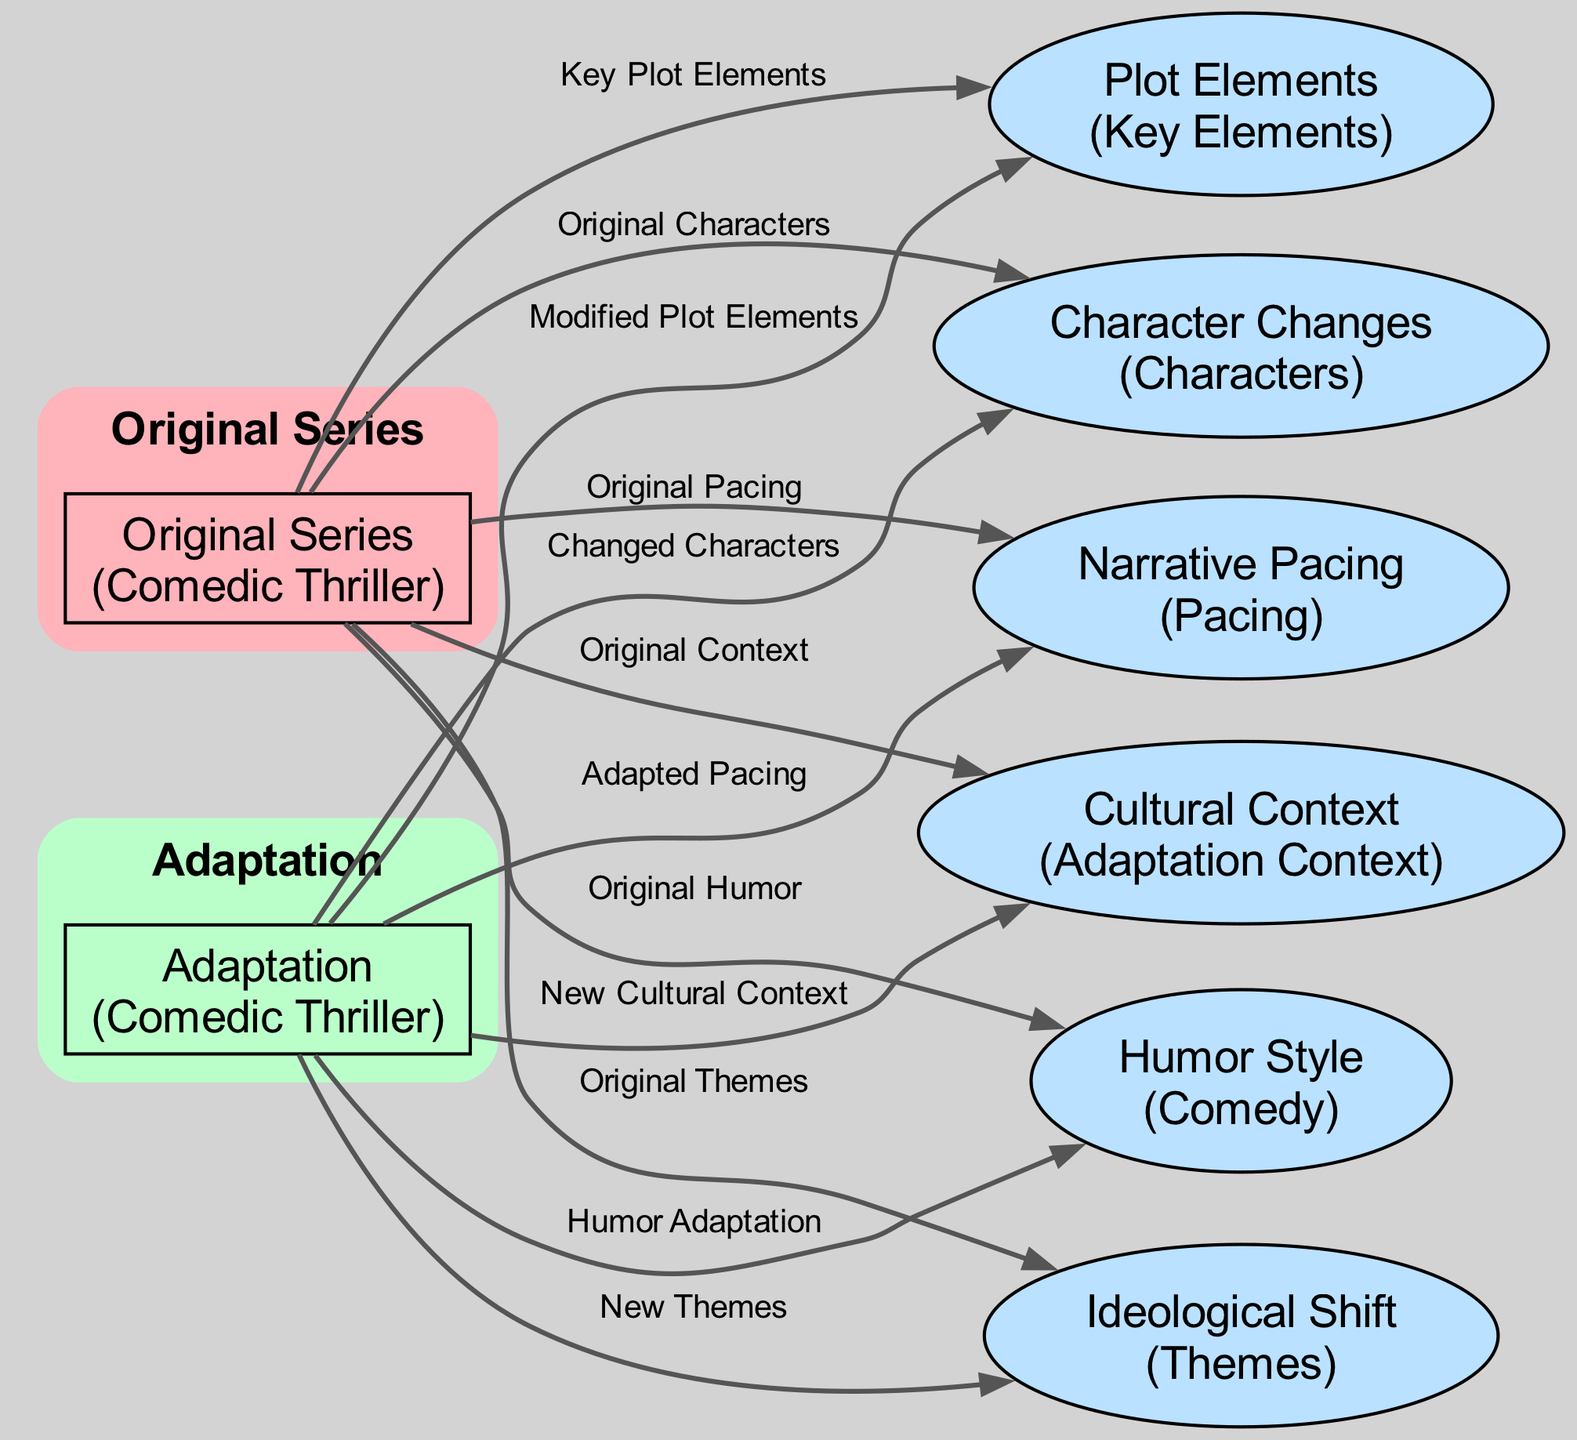What are the key plot elements of the original series? The diagram indicates that the original series has key plot elements, denoted by the edge labeled "Key Plot Elements" leading from "Original Series" to "Plot Elements."
Answer: Key Plot Elements What are the modified plot elements in the adaptation? The adaptation has modified plot elements, as labeled by the edge from "Adaptation" to "Plot Elements" marked "Modified Plot Elements."
Answer: Modified Plot Elements How many nodes are present in this diagram? Counting the nodes listed, there are a total of 7 nodes: Original Series, Adaptation, Plot Elements, Character Changes, Humor Style, Cultural Context, Narrative Pacing, and Ideological Shift.
Answer: 7 What change is associated with the characters in the adaptation? The diagram indicates that the adaptation features changed characters, as described by the edge leading from "Adaptation" to "Character Changes" labeled "Changed Characters."
Answer: Changed Characters How does the humor style differ between the original and the adaptation? The original series showcases original humor while the adaptation showcases humor adaptation, indicated by the respective edges between both series and the node "Humor Style."
Answer: Humor Adaptation Which aspect of adaptation provides cultural context? The adaptation provides new cultural context, as indicated by the edge leading from "Adaptation" to "Cultural Context" labeled "New Cultural Context."
Answer: New Cultural Context What is the ideological shift regarding themes in the adaptation? The adaptation presents new themes, shown by the edge leading from "Adaptation" to "Ideological Shift" labeled "New Themes," compared to the original themes from the original series.
Answer: New Themes Which node is linked to narrative pacing for both series? The node "Narrative Pacing" is linked to both series, where the original series shows original pacing and the adaptation illustrates adapted pacing, connected through edges from both nodes.
Answer: Narrative Pacing What does the edge between Original Series and Humor Style indicate? The edge labeled "Original Humor" indicates that the original series features a distinct style of humor, pointing to the "Humor Style" node from "Original Series."
Answer: Original Humor 